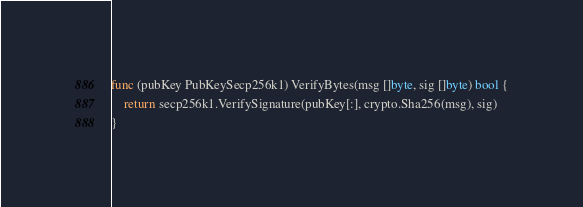<code> <loc_0><loc_0><loc_500><loc_500><_Go_>
func (pubKey PubKeySecp256k1) VerifyBytes(msg []byte, sig []byte) bool {
	return secp256k1.VerifySignature(pubKey[:], crypto.Sha256(msg), sig)
}
</code> 